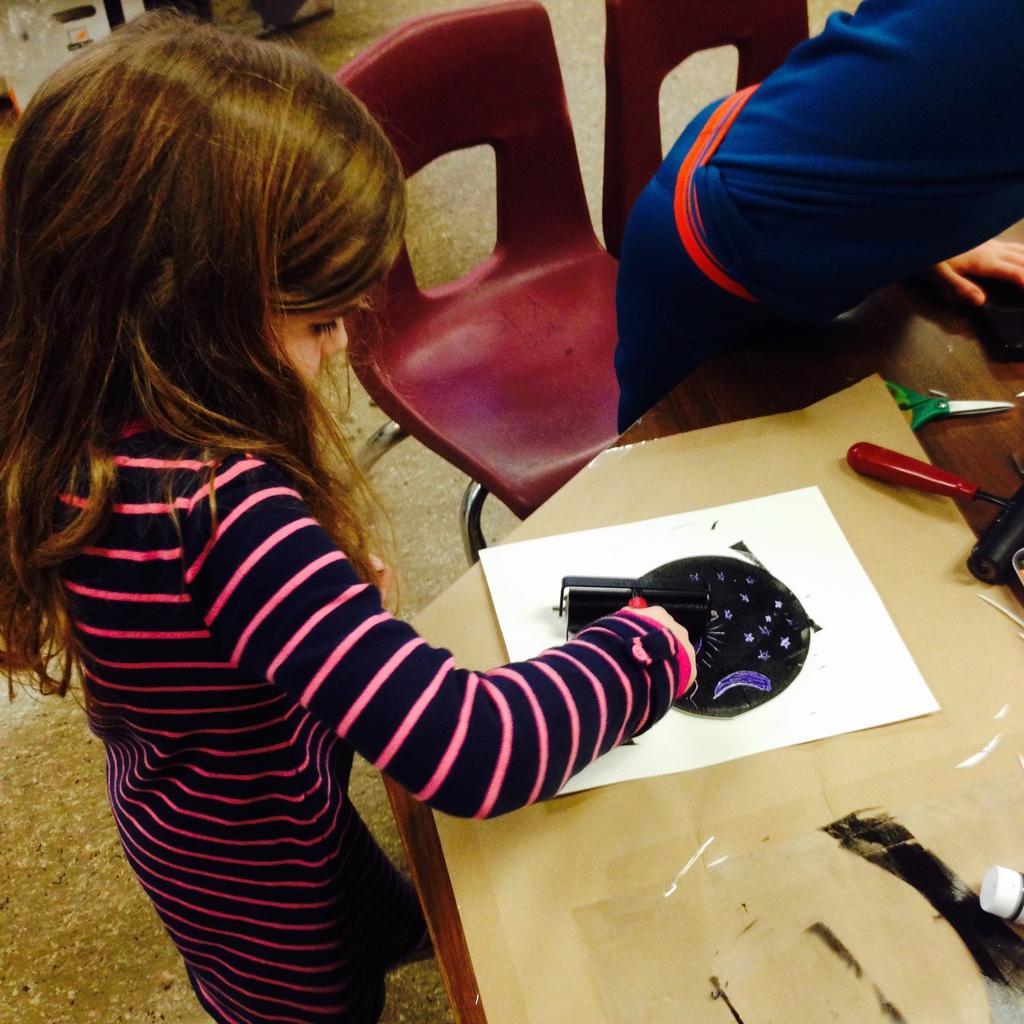In one or two sentences, can you explain what this image depicts? In this image we can see a children standing. On the table there is a paper,scissor and there is a chair. 